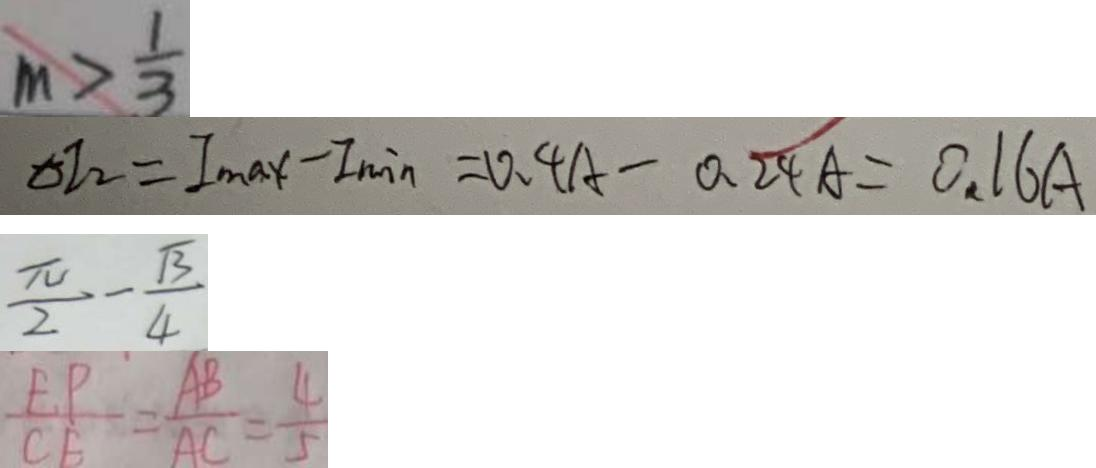Convert formula to latex. <formula><loc_0><loc_0><loc_500><loc_500>m > \frac { 1 } { 3 } 
 \Delta I _ { 2 } = I _ { \max } - I _ { \min } = 0 . 4 A - 0 . 2 4 A = 0 . 1 6 A 
 \frac { \pi } { 2 } - \frac { \sqrt { 3 } } { 4 } 
 \frac { E P } { C E } = \frac { A B } { A C } = \frac { 4 } { 5 }</formula> 